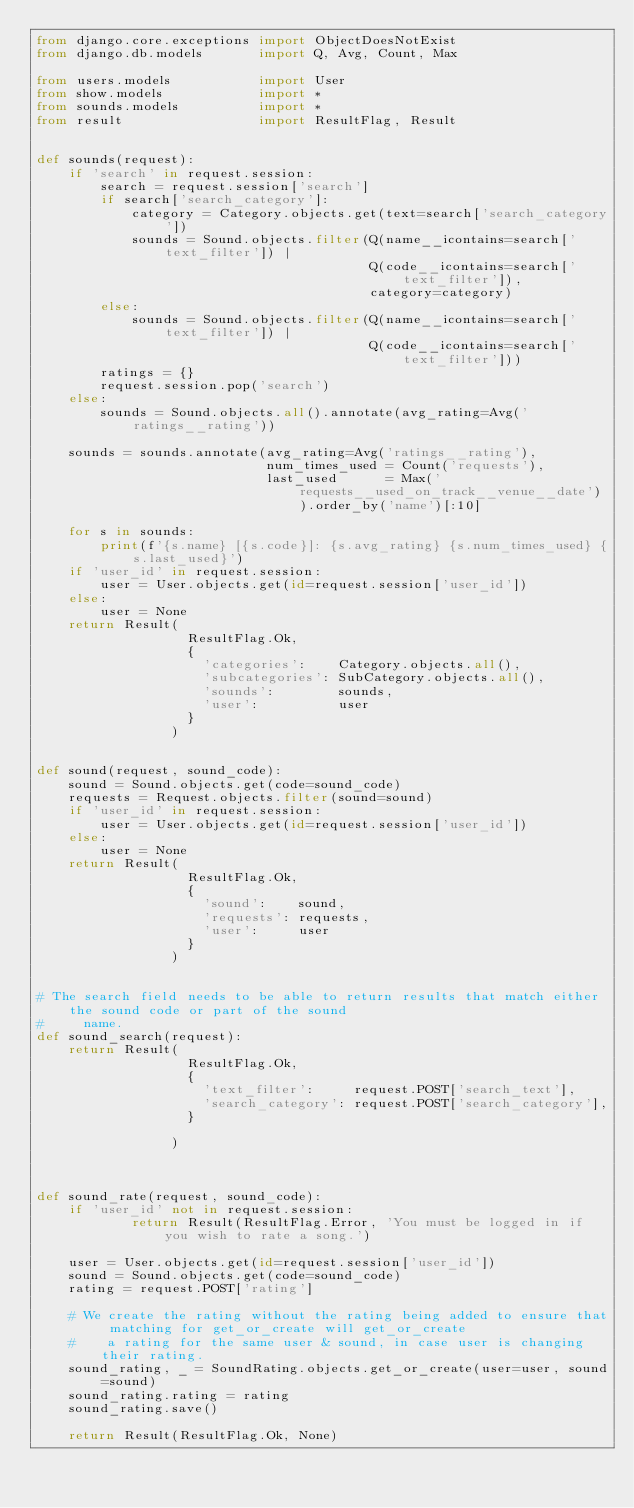Convert code to text. <code><loc_0><loc_0><loc_500><loc_500><_Python_>from django.core.exceptions import ObjectDoesNotExist
from django.db.models       import Q, Avg, Count, Max

from users.models           import User
from show.models            import *
from sounds.models          import *
from result                 import ResultFlag, Result


def sounds(request):
    if 'search' in request.session:
        search = request.session['search']
        if search['search_category']:
            category = Category.objects.get(text=search['search_category'])
            sounds = Sound.objects.filter(Q(name__icontains=search['text_filter']) |
                                          Q(code__icontains=search['text_filter']),
                                          category=category)
        else:
            sounds = Sound.objects.filter(Q(name__icontains=search['text_filter']) |
                                          Q(code__icontains=search['text_filter']))
        ratings = {}
        request.session.pop('search')
    else:
        sounds = Sound.objects.all().annotate(avg_rating=Avg('ratings__rating'))
        
    sounds = sounds.annotate(avg_rating=Avg('ratings__rating'),
                             num_times_used = Count('requests'),
                             last_used      = Max('requests__used_on_track__venue__date')).order_by('name')[:10]
    
    for s in sounds:
        print(f'{s.name} [{s.code}]: {s.avg_rating} {s.num_times_used} {s.last_used}')
    if 'user_id' in request.session:
        user = User.objects.get(id=request.session['user_id'])
    else:
        user = None
    return Result(
                   ResultFlag.Ok,
                   {
                     'categories':    Category.objects.all(),
                     'subcategories': SubCategory.objects.all(),
                     'sounds':        sounds,
                     'user':          user
                   }
                 )


def sound(request, sound_code):
    sound = Sound.objects.get(code=sound_code)
    requests = Request.objects.filter(sound=sound)
    if 'user_id' in request.session:
        user = User.objects.get(id=request.session['user_id'])
    else:
        user = None
    return Result(
                   ResultFlag.Ok,
                   {
                     'sound':    sound,
                     'requests': requests,
                     'user':     user
                   }
                 )


# The search field needs to be able to return results that match either the sound code or part of the sound
#     name.
def sound_search(request):
    return Result(
                   ResultFlag.Ok,
                   {
                     'text_filter':     request.POST['search_text'],
                     'search_category': request.POST['search_category'],
                   }

                 )



def sound_rate(request, sound_code):
    if 'user_id' not in request.session:
            return Result(ResultFlag.Error, 'You must be logged in if you wish to rate a song.')

    user = User.objects.get(id=request.session['user_id'])
    sound = Sound.objects.get(code=sound_code)
    rating = request.POST['rating']

    # We create the rating without the rating being added to ensure that matching for get_or_create will get_or_create
    #    a rating for the same user & sound, in case user is changing their rating.
    sound_rating, _ = SoundRating.objects.get_or_create(user=user, sound=sound)
    sound_rating.rating = rating
    sound_rating.save()

    return Result(ResultFlag.Ok, None)
</code> 